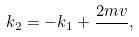Convert formula to latex. <formula><loc_0><loc_0><loc_500><loc_500>k _ { 2 } = - k _ { 1 } + \frac { 2 m v } { } ,</formula> 